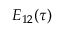<formula> <loc_0><loc_0><loc_500><loc_500>E _ { 1 2 } ( \tau )</formula> 